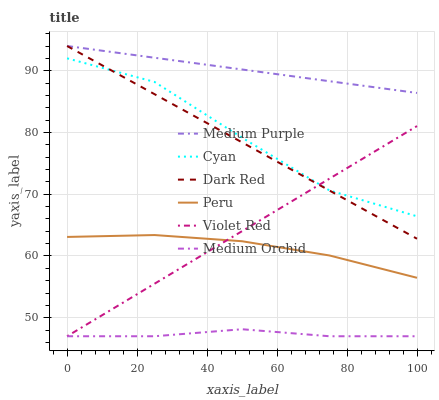Does Medium Orchid have the minimum area under the curve?
Answer yes or no. Yes. Does Medium Purple have the maximum area under the curve?
Answer yes or no. Yes. Does Dark Red have the minimum area under the curve?
Answer yes or no. No. Does Dark Red have the maximum area under the curve?
Answer yes or no. No. Is Medium Purple the smoothest?
Answer yes or no. Yes. Is Cyan the roughest?
Answer yes or no. Yes. Is Dark Red the smoothest?
Answer yes or no. No. Is Dark Red the roughest?
Answer yes or no. No. Does Violet Red have the lowest value?
Answer yes or no. Yes. Does Dark Red have the lowest value?
Answer yes or no. No. Does Medium Purple have the highest value?
Answer yes or no. Yes. Does Medium Orchid have the highest value?
Answer yes or no. No. Is Violet Red less than Medium Purple?
Answer yes or no. Yes. Is Cyan greater than Medium Orchid?
Answer yes or no. Yes. Does Violet Red intersect Medium Orchid?
Answer yes or no. Yes. Is Violet Red less than Medium Orchid?
Answer yes or no. No. Is Violet Red greater than Medium Orchid?
Answer yes or no. No. Does Violet Red intersect Medium Purple?
Answer yes or no. No. 